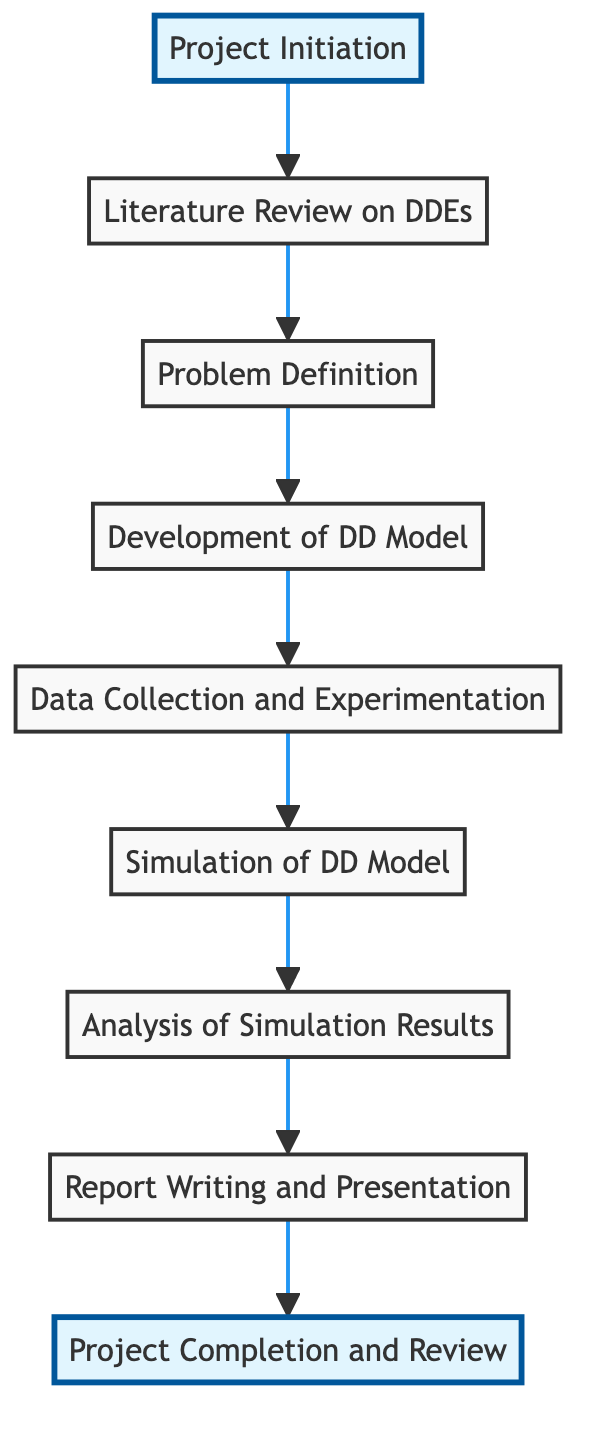What is the first step in the project timeline? The first step in the project timeline is represented by the node labeled "Project Initiation." This node does not have any incoming edges, indicating that it is the starting point of the process.
Answer: Project Initiation How many nodes are present in the diagram? By counting the individual nodes listed, there are nine nodes in total: Project Initiation, Literature Review on Delay Differential Equations, Problem Definition, Development of Delay Differential Model, Data Collection and Experimentation, Simulation of the Delay Differential Model, Analysis of Simulation Results, Report Writing and Presentation Preparation, and Project Completion and Review.
Answer: 9 What follows after the Analysis of Simulation Results? The node immediately following "Analysis of Simulation Results" is "Report Writing and Presentation Preparation," which is connected by a directed edge indicating it is the next step after the analysis phase.
Answer: Report Writing and Presentation Preparation Which node represents the last step in the project timeline? The last step in the project timeline is indicated by the node labeled "Project Completion and Review." This node has no outgoing edges, signifying that it is the endpoint of the process.
Answer: Project Completion and Review How many edges connect the nodes in this diagram? By counting the connections between the nodes (edges), there are eight directed edges that show the flow from one step to its subsequent step throughout the project timeline.
Answer: 8 What is the relationship between Problem Definition and Literature Review? The relationship is that "Literature Review on Delay Differential Equations" is a prerequisite to "Problem Definition," as indicated by the directed edge connecting these two nodes in the diagram.
Answer: Prerequisite What are the two highlighted nodes in the diagram? The highlighted nodes are "Project Initiation" and "Project Completion and Review." These nodes are visually emphasized, indicating they are key start and end points of the project timeline.
Answer: Project Initiation, Project Completion and Review Which phase includes the collection of data? The phase that includes data collection is labeled "Data Collection and Experimentation." It follows the development of the delay differential model as the next step in the timeline.
Answer: Data Collection and Experimentation Which step comes before the Simulation of the Delay Differential Model? The step that comes directly before "Simulation of the Delay Differential Model" is "Data Collection and Experimentation," as indicated by the directed edge connecting them in the graph.
Answer: Data Collection and Experimentation 